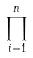<formula> <loc_0><loc_0><loc_500><loc_500>\prod _ { i = 1 } ^ { n }</formula> 